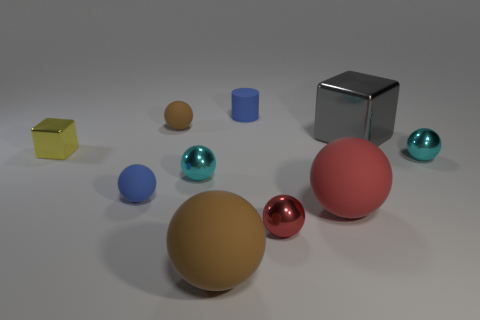Subtract 4 spheres. How many spheres are left? 3 Subtract all small brown matte spheres. How many spheres are left? 6 Add 1 blue objects. How many blue objects are left? 3 Add 6 tiny rubber cylinders. How many tiny rubber cylinders exist? 7 Subtract all gray blocks. How many blocks are left? 1 Subtract 0 cyan blocks. How many objects are left? 10 Subtract all cylinders. How many objects are left? 9 Subtract all gray cylinders. Subtract all red cubes. How many cylinders are left? 1 Subtract all purple balls. How many gray blocks are left? 1 Subtract all small cubes. Subtract all cyan metal spheres. How many objects are left? 7 